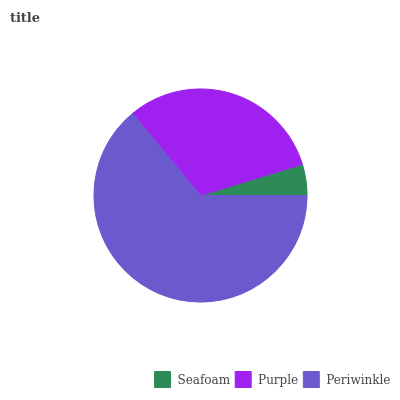Is Seafoam the minimum?
Answer yes or no. Yes. Is Periwinkle the maximum?
Answer yes or no. Yes. Is Purple the minimum?
Answer yes or no. No. Is Purple the maximum?
Answer yes or no. No. Is Purple greater than Seafoam?
Answer yes or no. Yes. Is Seafoam less than Purple?
Answer yes or no. Yes. Is Seafoam greater than Purple?
Answer yes or no. No. Is Purple less than Seafoam?
Answer yes or no. No. Is Purple the high median?
Answer yes or no. Yes. Is Purple the low median?
Answer yes or no. Yes. Is Seafoam the high median?
Answer yes or no. No. Is Periwinkle the low median?
Answer yes or no. No. 